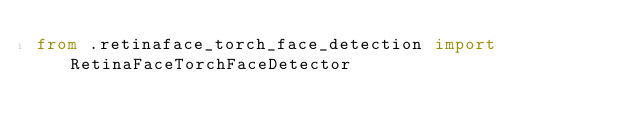<code> <loc_0><loc_0><loc_500><loc_500><_Python_>from .retinaface_torch_face_detection import RetinaFaceTorchFaceDetector
</code> 